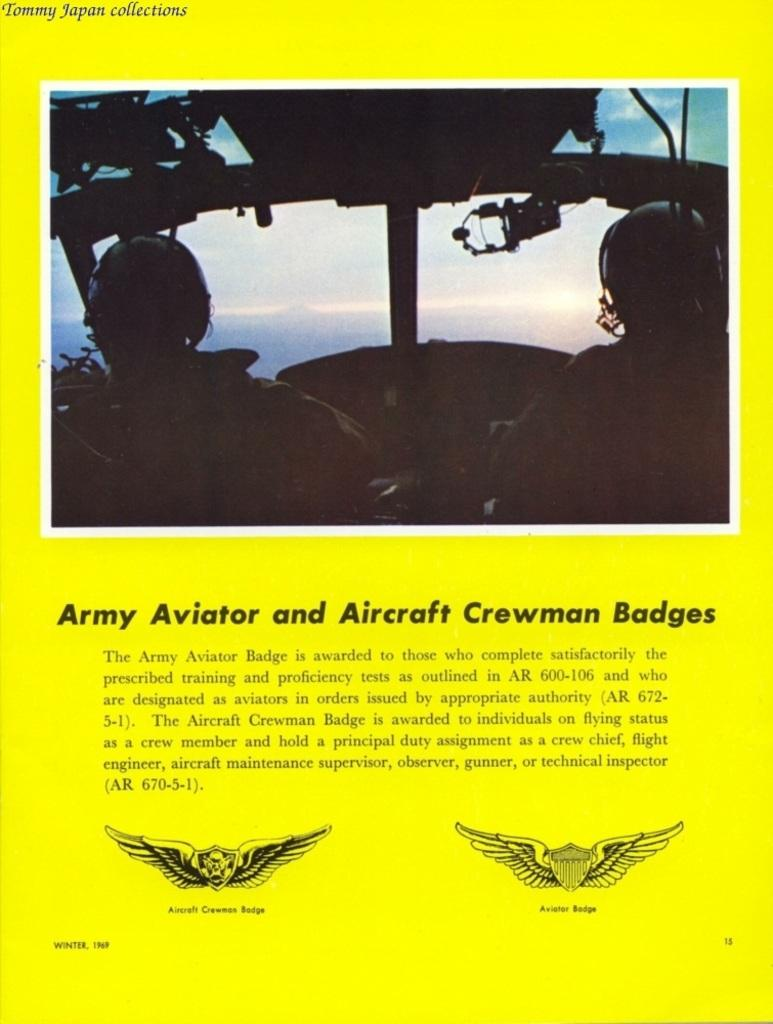What type of visual is the image? The image is a poster. What can be found on the poster besides visual elements? There is writing on the poster. Are there any symbols or brand identifiers on the poster? Yes, there are logos on the poster. How many people are depicted in the image? There are two people in the image. Can you tell me how many sheep are visible in the image? There are no sheep present in the image; it is a poster with writing, logos, and two people. What type of zephyr is blowing in the image? There is no zephyr present in the image. 